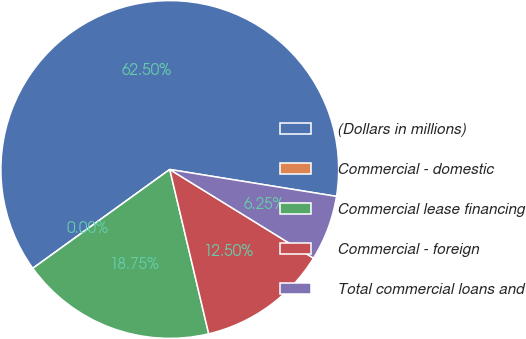Convert chart. <chart><loc_0><loc_0><loc_500><loc_500><pie_chart><fcel>(Dollars in millions)<fcel>Commercial - domestic<fcel>Commercial lease financing<fcel>Commercial - foreign<fcel>Total commercial loans and<nl><fcel>62.49%<fcel>0.0%<fcel>18.75%<fcel>12.5%<fcel>6.25%<nl></chart> 